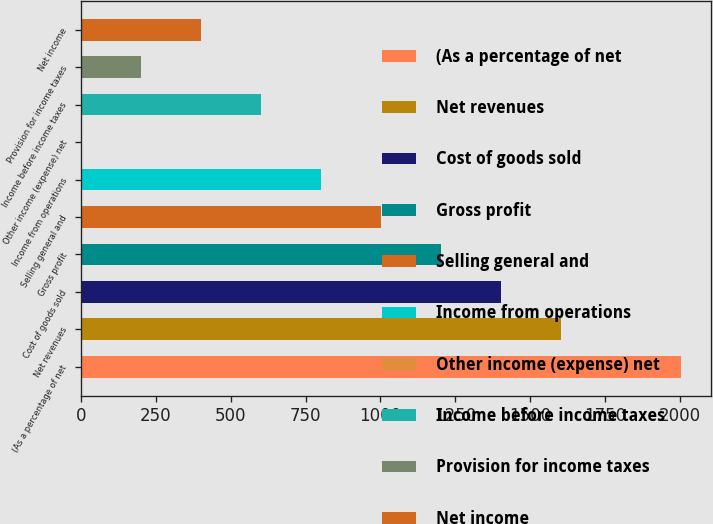<chart> <loc_0><loc_0><loc_500><loc_500><bar_chart><fcel>(As a percentage of net<fcel>Net revenues<fcel>Cost of goods sold<fcel>Gross profit<fcel>Selling general and<fcel>Income from operations<fcel>Other income (expense) net<fcel>Income before income taxes<fcel>Provision for income taxes<fcel>Net income<nl><fcel>2004<fcel>1603.32<fcel>1402.98<fcel>1202.64<fcel>1002.3<fcel>801.96<fcel>0.6<fcel>601.62<fcel>200.94<fcel>401.28<nl></chart> 